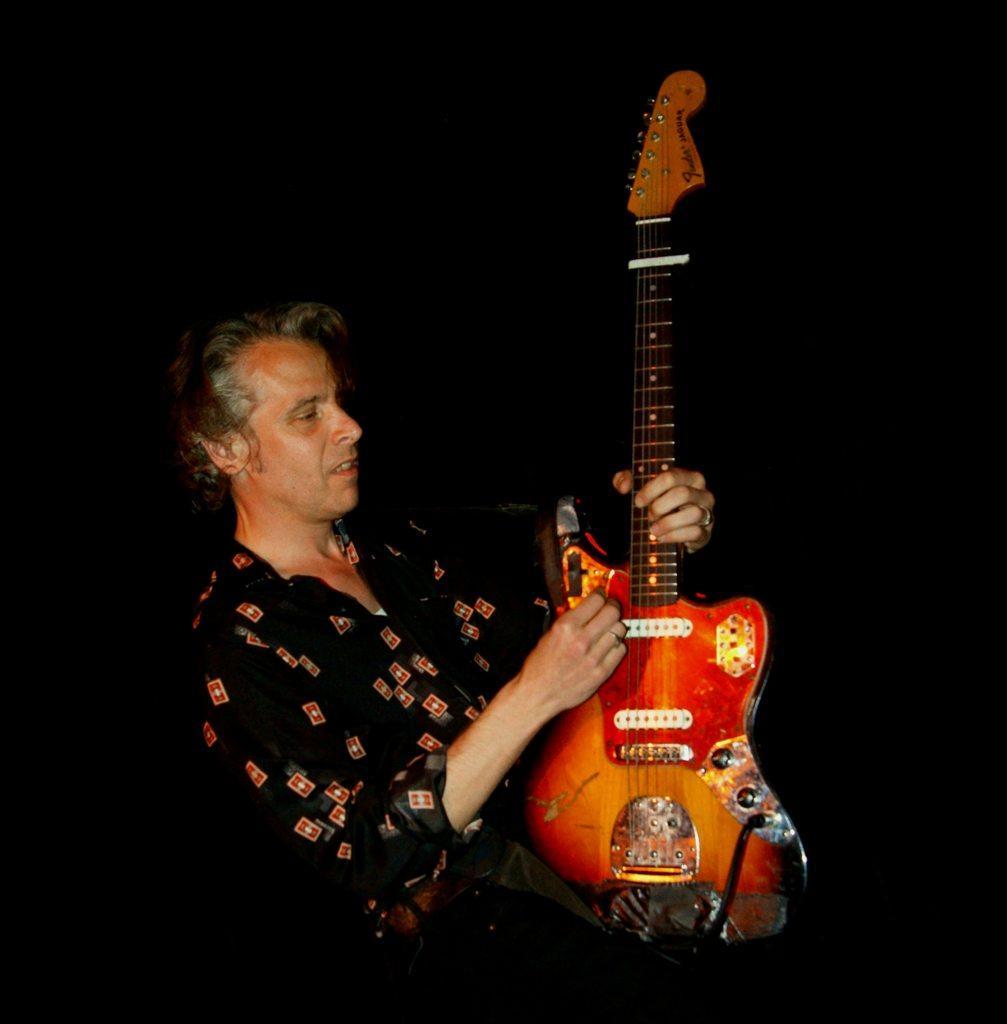Describe this image in one or two sentences. In this image we can see a man holding a guitar. 